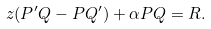Convert formula to latex. <formula><loc_0><loc_0><loc_500><loc_500>z ( P ^ { \prime } Q - P Q ^ { \prime } ) + \alpha P Q = R .</formula> 